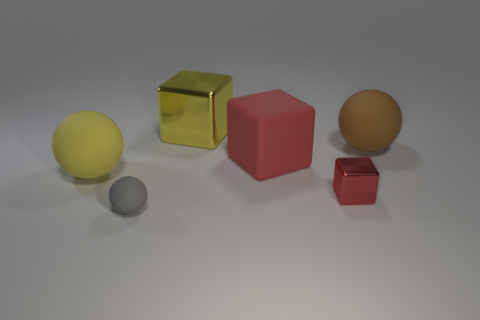Subtract all yellow matte balls. How many balls are left? 2 Add 2 large yellow rubber things. How many objects exist? 8 Subtract all yellow cubes. How many cubes are left? 2 Subtract all tiny green shiny cubes. Subtract all big rubber balls. How many objects are left? 4 Add 6 yellow metallic things. How many yellow metallic things are left? 7 Add 3 red rubber cylinders. How many red rubber cylinders exist? 3 Subtract 1 gray balls. How many objects are left? 5 Subtract 1 cubes. How many cubes are left? 2 Subtract all cyan balls. Subtract all cyan blocks. How many balls are left? 3 Subtract all green blocks. How many gray balls are left? 1 